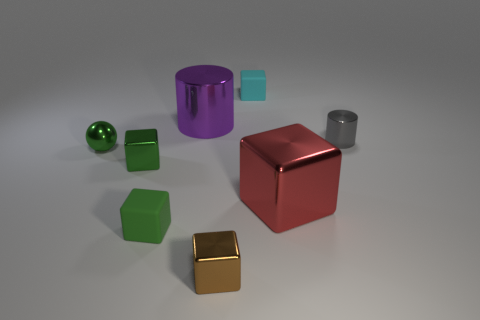Subtract all red cubes. How many cubes are left? 4 Subtract 2 blocks. How many blocks are left? 3 Subtract all red blocks. How many blocks are left? 4 Subtract all purple blocks. Subtract all brown balls. How many blocks are left? 5 Add 1 blue metal things. How many objects exist? 9 Subtract all spheres. How many objects are left? 7 Add 6 red metallic cubes. How many red metallic cubes exist? 7 Subtract 0 gray cubes. How many objects are left? 8 Subtract all big blue cylinders. Subtract all red shiny objects. How many objects are left? 7 Add 2 gray cylinders. How many gray cylinders are left? 3 